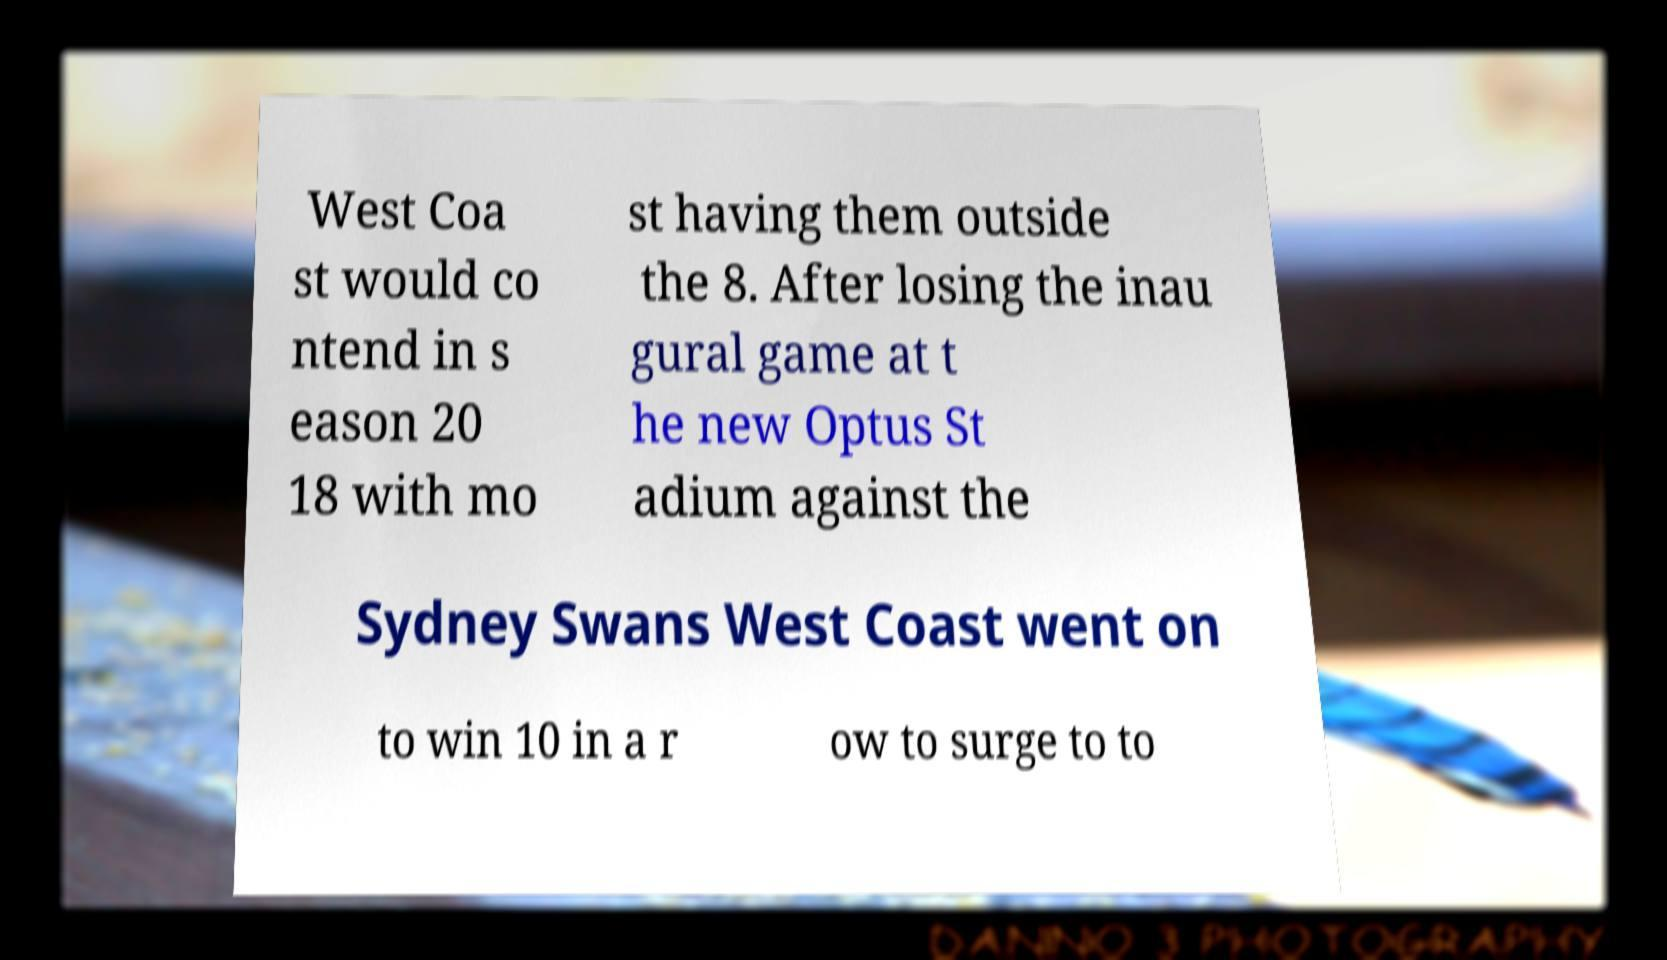Can you accurately transcribe the text from the provided image for me? West Coa st would co ntend in s eason 20 18 with mo st having them outside the 8. After losing the inau gural game at t he new Optus St adium against the Sydney Swans West Coast went on to win 10 in a r ow to surge to to 